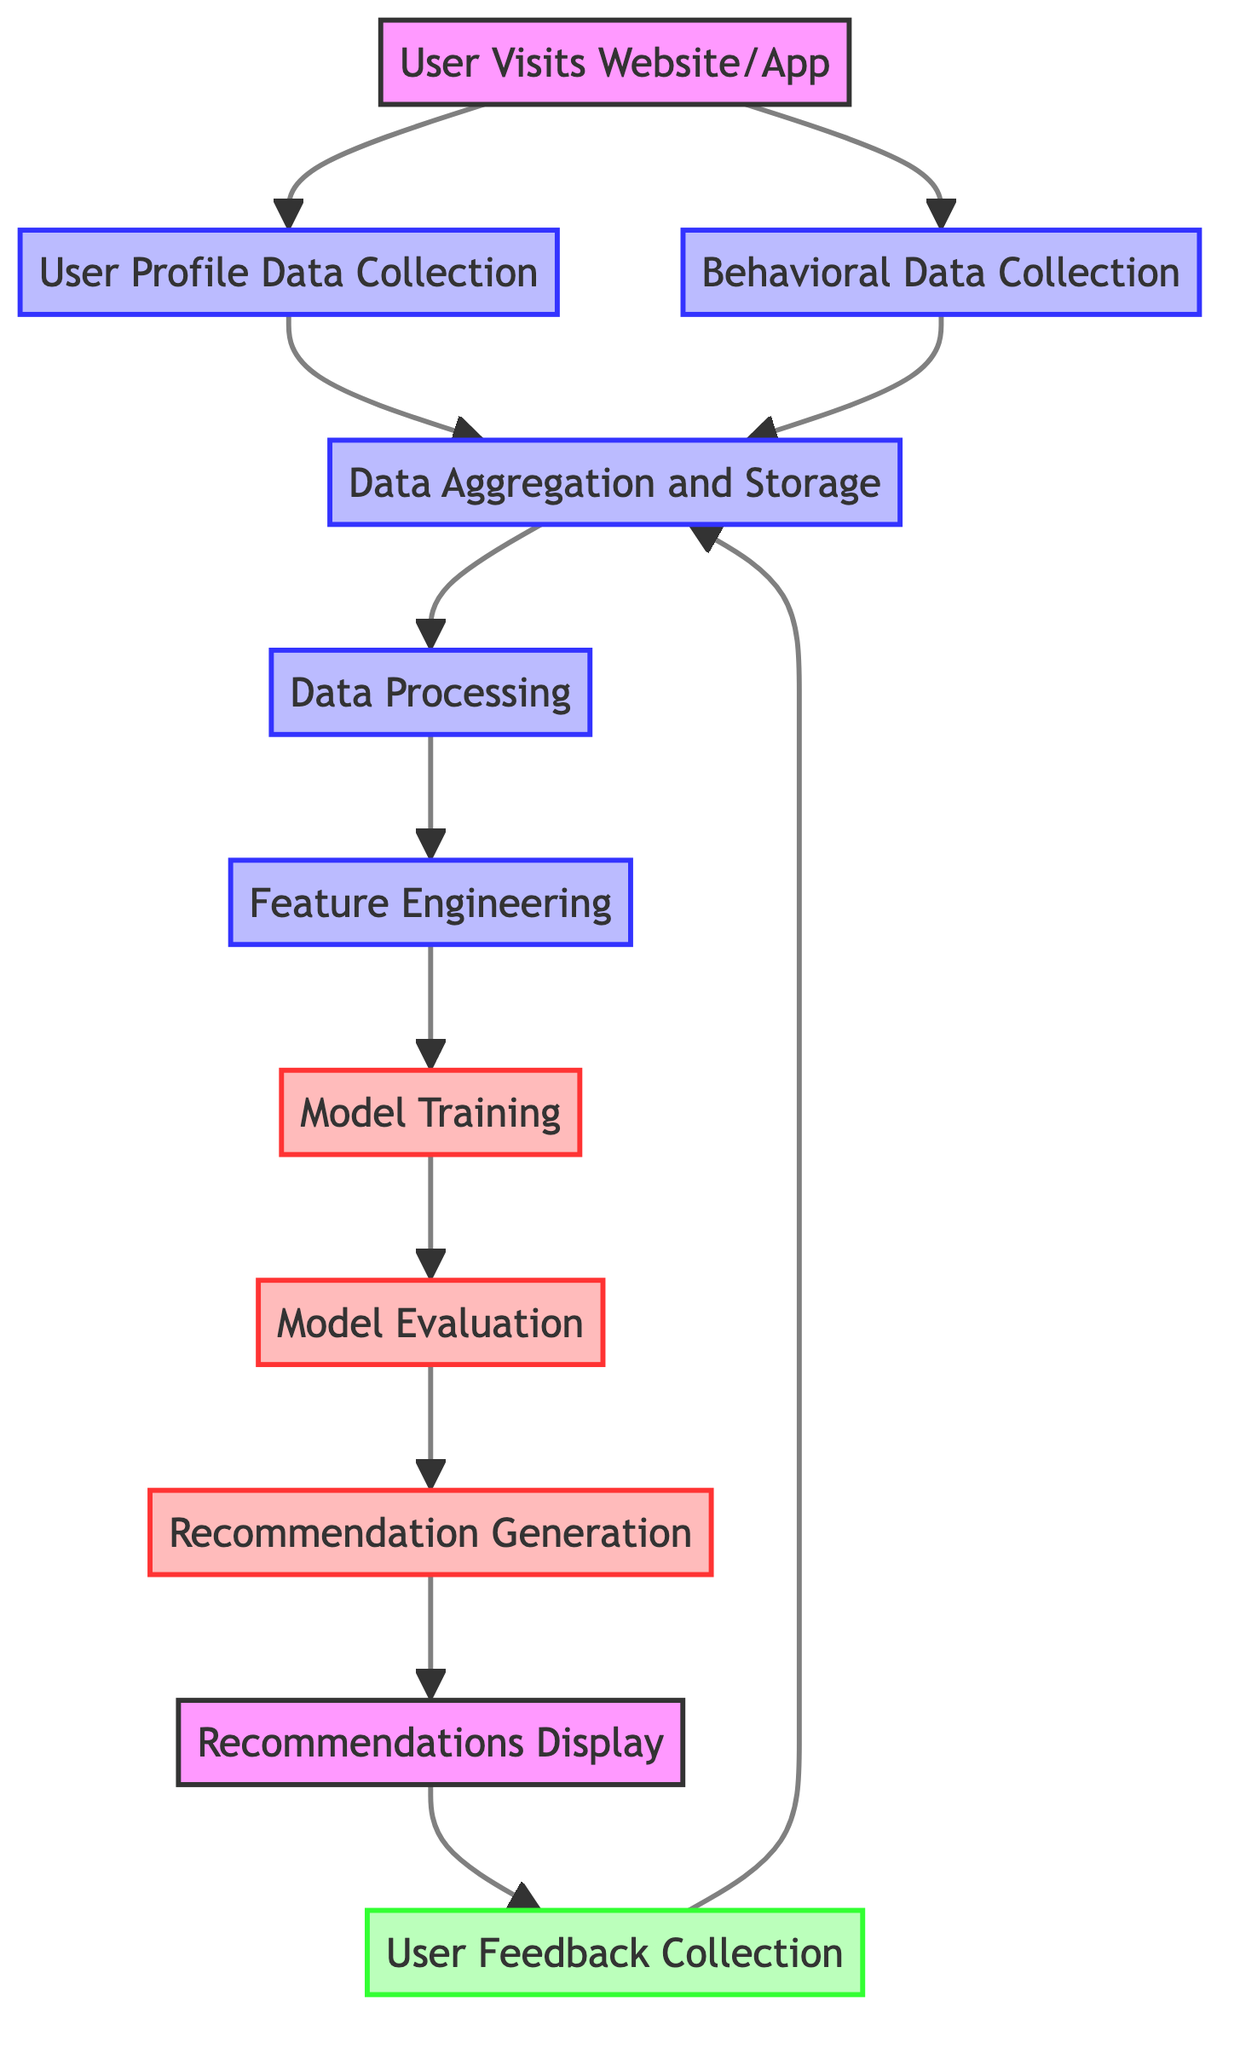What is the first step taken by the user in this flow chart? The first step in the flow chart is indicated by the first node, which is "User Visits Website/App." This initiates the entire process.
Answer: User Visits Website/App How many main processes are involved from data collection to recommendations display? Counting the main processes involved from "User Profile Data Collection" to "Recommendations Display," we see a total of seven distinct processes (B to J).
Answer: Seven What data collection occurs after user profile data collection? After "User Profile Data Collection," the next step is "Behavioral Data Collection," which tracks user behaviors like clicks and purchases.
Answer: Behavioral Data Collection Which element follows data processing in the flow chart? The element that follows "Data Processing" is "Feature Engineering," as shown in the arrows indicating the flow from E to F.
Answer: Feature Engineering What happens to user feedback in this system? User feedback is collected in the "User Feedback Collection" stage and then loops back to "Data Aggregation and Storage," indicating that feedback informs future data processes.
Answer: It loops back to Data Aggregation and Storage Which step uses machine learning algorithms to train models? The step that employs machine learning algorithms for training is "Model Training," as indicated by node G in the flow chart.
Answer: Model Training What is the purpose of "Model Evaluation"? The purpose of "Model Evaluation" is to assess the performance of the recommendation models based on various metrics such as RMSE and precision.
Answer: To assess model performance How many feedback loops are present in the flow chart? There is one feedback loop indicated in the flow chart, which goes from "User Feedback Collection" back to "Data Aggregation and Storage."
Answer: One What action occurs just before recommendations display? Just before "Recommendations Display," the action taken is "Recommendation Generation," where personalized recommendations are created.
Answer: Recommendation Generation 